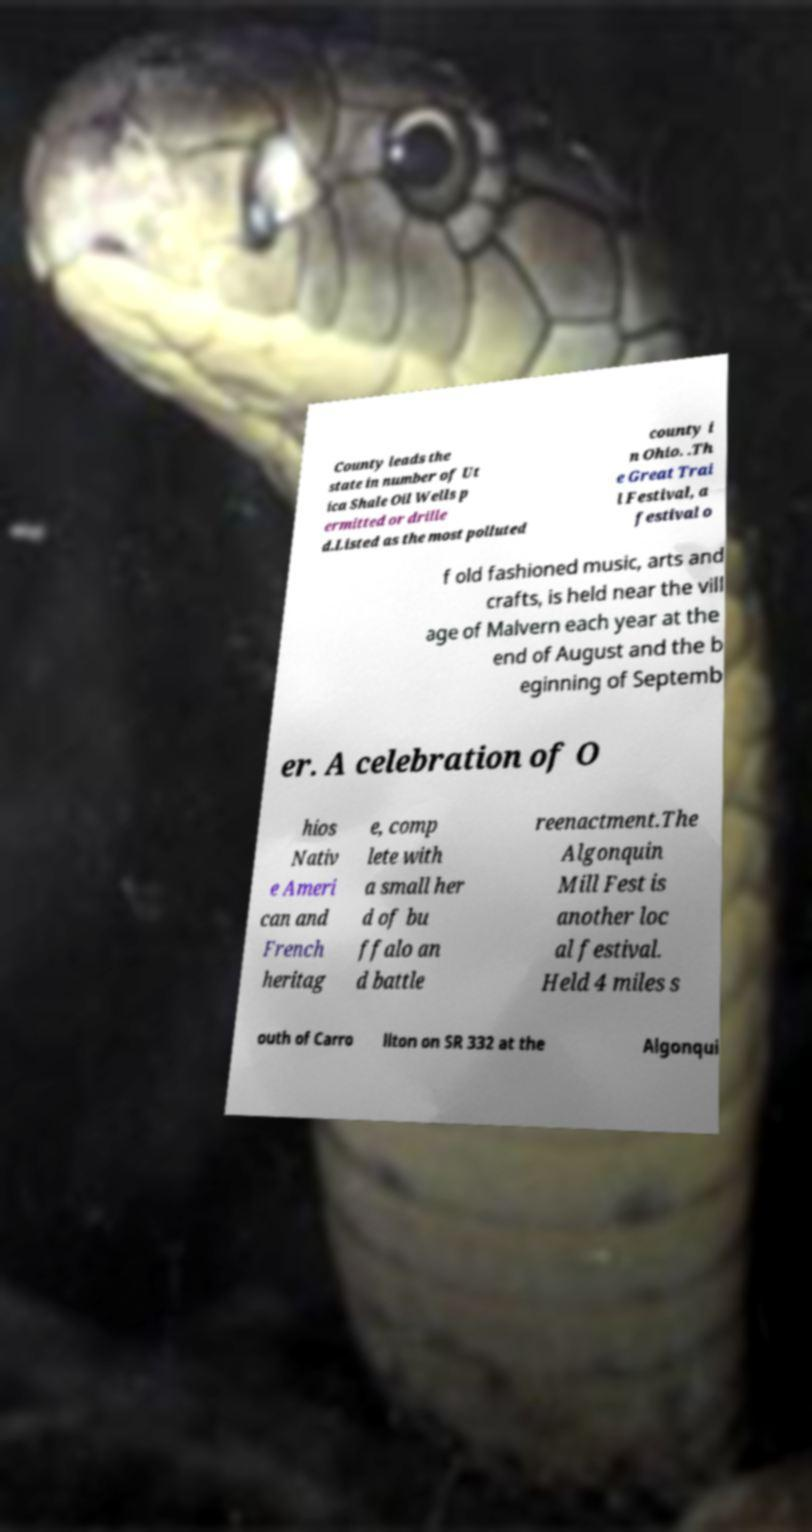For documentation purposes, I need the text within this image transcribed. Could you provide that? County leads the state in number of Ut ica Shale Oil Wells p ermitted or drille d.Listed as the most polluted county i n Ohio. .Th e Great Trai l Festival, a festival o f old fashioned music, arts and crafts, is held near the vill age of Malvern each year at the end of August and the b eginning of Septemb er. A celebration of O hios Nativ e Ameri can and French heritag e, comp lete with a small her d of bu ffalo an d battle reenactment.The Algonquin Mill Fest is another loc al festival. Held 4 miles s outh of Carro llton on SR 332 at the Algonqui 